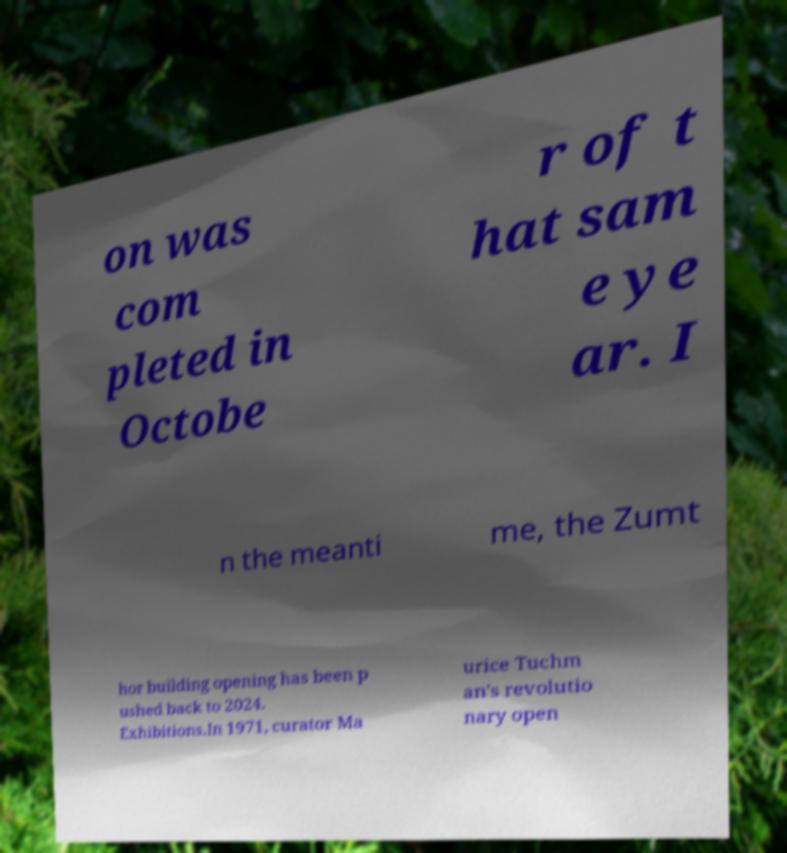Can you accurately transcribe the text from the provided image for me? on was com pleted in Octobe r of t hat sam e ye ar. I n the meanti me, the Zumt hor building opening has been p ushed back to 2024. Exhibitions.In 1971, curator Ma urice Tuchm an's revolutio nary open 